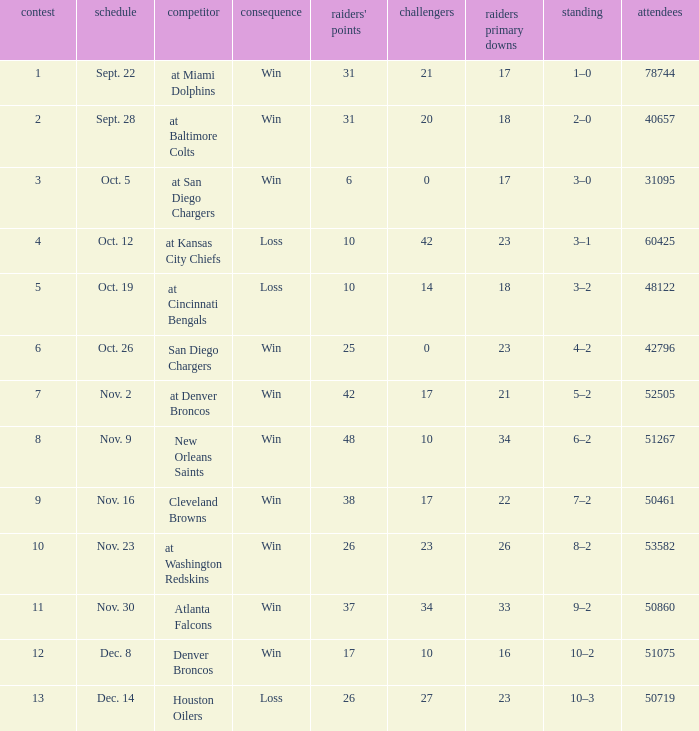Who was the game attended by 60425 people played against? At kansas city chiefs. 